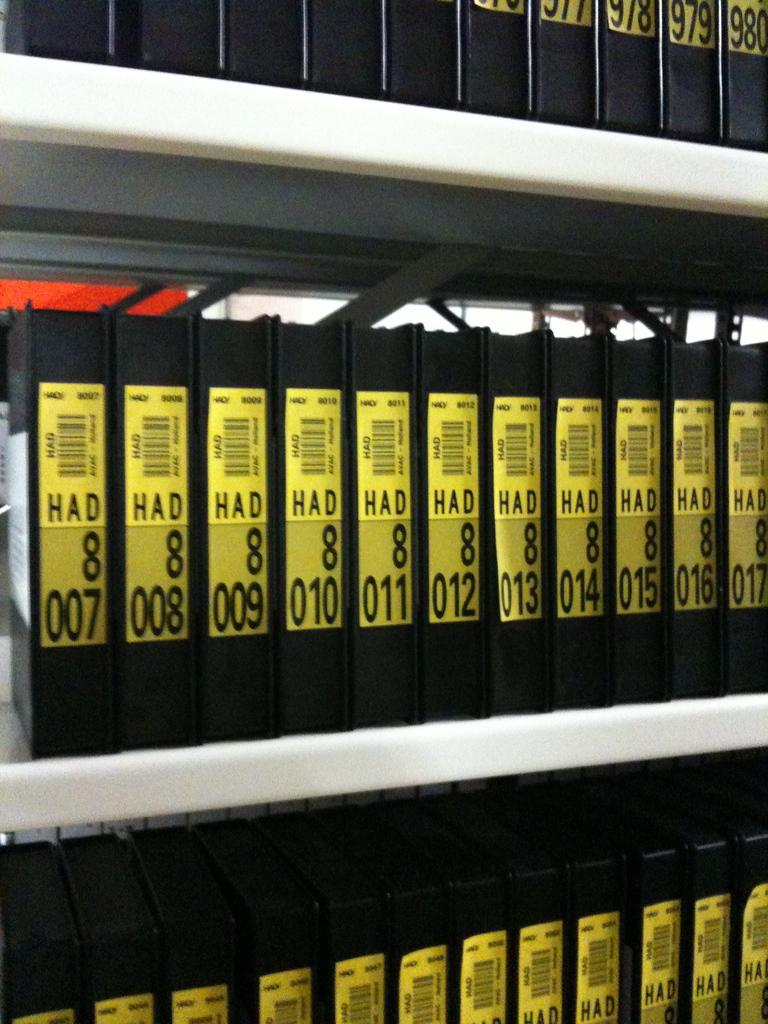<image>
Summarize the visual content of the image. A collection of Black items with yellow labels with a range of numbers 007-016 